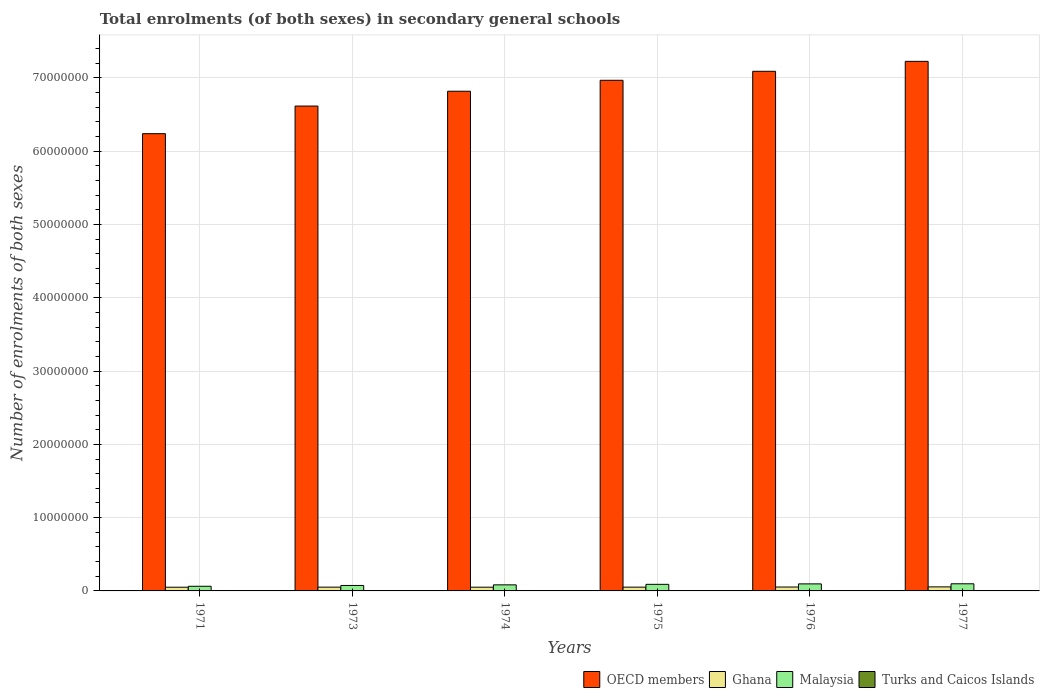Are the number of bars on each tick of the X-axis equal?
Keep it short and to the point. Yes. How many bars are there on the 6th tick from the left?
Your response must be concise. 4. How many bars are there on the 2nd tick from the right?
Give a very brief answer. 4. What is the label of the 6th group of bars from the left?
Give a very brief answer. 1977. In how many cases, is the number of bars for a given year not equal to the number of legend labels?
Offer a very short reply. 0. What is the number of enrolments in secondary schools in Turks and Caicos Islands in 1975?
Keep it short and to the point. 639. Across all years, what is the maximum number of enrolments in secondary schools in OECD members?
Give a very brief answer. 7.23e+07. Across all years, what is the minimum number of enrolments in secondary schools in OECD members?
Provide a short and direct response. 6.24e+07. In which year was the number of enrolments in secondary schools in OECD members minimum?
Your response must be concise. 1971. What is the total number of enrolments in secondary schools in Turks and Caicos Islands in the graph?
Your answer should be very brief. 3029. What is the difference between the number of enrolments in secondary schools in Turks and Caicos Islands in 1974 and that in 1977?
Provide a short and direct response. -204. What is the difference between the number of enrolments in secondary schools in Ghana in 1973 and the number of enrolments in secondary schools in Malaysia in 1974?
Make the answer very short. -3.13e+05. What is the average number of enrolments in secondary schools in OECD members per year?
Provide a succinct answer. 6.83e+07. In the year 1971, what is the difference between the number of enrolments in secondary schools in Ghana and number of enrolments in secondary schools in Malaysia?
Provide a short and direct response. -1.29e+05. In how many years, is the number of enrolments in secondary schools in Turks and Caicos Islands greater than 42000000?
Your response must be concise. 0. What is the ratio of the number of enrolments in secondary schools in Malaysia in 1974 to that in 1975?
Offer a terse response. 0.92. Is the difference between the number of enrolments in secondary schools in Ghana in 1974 and 1977 greater than the difference between the number of enrolments in secondary schools in Malaysia in 1974 and 1977?
Your answer should be compact. Yes. What is the difference between the highest and the second highest number of enrolments in secondary schools in Malaysia?
Make the answer very short. 1.25e+04. What is the difference between the highest and the lowest number of enrolments in secondary schools in Ghana?
Your answer should be very brief. 4.61e+04. Is the sum of the number of enrolments in secondary schools in Malaysia in 1974 and 1975 greater than the maximum number of enrolments in secondary schools in OECD members across all years?
Your response must be concise. No. What does the 3rd bar from the left in 1973 represents?
Ensure brevity in your answer.  Malaysia. How many bars are there?
Provide a succinct answer. 24. How many years are there in the graph?
Your answer should be compact. 6. Are the values on the major ticks of Y-axis written in scientific E-notation?
Give a very brief answer. No. Where does the legend appear in the graph?
Offer a very short reply. Bottom right. How many legend labels are there?
Your answer should be compact. 4. What is the title of the graph?
Give a very brief answer. Total enrolments (of both sexes) in secondary general schools. What is the label or title of the Y-axis?
Your answer should be compact. Number of enrolments of both sexes. What is the Number of enrolments of both sexes of OECD members in 1971?
Your answer should be very brief. 6.24e+07. What is the Number of enrolments of both sexes of Ghana in 1971?
Your answer should be very brief. 5.06e+05. What is the Number of enrolments of both sexes in Malaysia in 1971?
Provide a succinct answer. 6.35e+05. What is the Number of enrolments of both sexes of Turks and Caicos Islands in 1971?
Your answer should be very brief. 227. What is the Number of enrolments of both sexes in OECD members in 1973?
Your answer should be very brief. 6.62e+07. What is the Number of enrolments of both sexes of Ghana in 1973?
Provide a short and direct response. 5.16e+05. What is the Number of enrolments of both sexes of Malaysia in 1973?
Make the answer very short. 7.45e+05. What is the Number of enrolments of both sexes in Turks and Caicos Islands in 1973?
Offer a very short reply. 354. What is the Number of enrolments of both sexes of OECD members in 1974?
Ensure brevity in your answer.  6.82e+07. What is the Number of enrolments of both sexes in Ghana in 1974?
Your response must be concise. 5.09e+05. What is the Number of enrolments of both sexes of Malaysia in 1974?
Ensure brevity in your answer.  8.29e+05. What is the Number of enrolments of both sexes of Turks and Caicos Islands in 1974?
Provide a succinct answer. 467. What is the Number of enrolments of both sexes of OECD members in 1975?
Keep it short and to the point. 6.97e+07. What is the Number of enrolments of both sexes in Ghana in 1975?
Provide a short and direct response. 5.14e+05. What is the Number of enrolments of both sexes of Malaysia in 1975?
Make the answer very short. 9.00e+05. What is the Number of enrolments of both sexes in Turks and Caicos Islands in 1975?
Your response must be concise. 639. What is the Number of enrolments of both sexes in OECD members in 1976?
Your answer should be very brief. 7.09e+07. What is the Number of enrolments of both sexes of Ghana in 1976?
Offer a very short reply. 5.33e+05. What is the Number of enrolments of both sexes of Malaysia in 1976?
Offer a very short reply. 9.61e+05. What is the Number of enrolments of both sexes in Turks and Caicos Islands in 1976?
Provide a succinct answer. 671. What is the Number of enrolments of both sexes in OECD members in 1977?
Give a very brief answer. 7.23e+07. What is the Number of enrolments of both sexes in Ghana in 1977?
Your answer should be very brief. 5.52e+05. What is the Number of enrolments of both sexes of Malaysia in 1977?
Offer a terse response. 9.74e+05. What is the Number of enrolments of both sexes in Turks and Caicos Islands in 1977?
Keep it short and to the point. 671. Across all years, what is the maximum Number of enrolments of both sexes in OECD members?
Your answer should be very brief. 7.23e+07. Across all years, what is the maximum Number of enrolments of both sexes in Ghana?
Give a very brief answer. 5.52e+05. Across all years, what is the maximum Number of enrolments of both sexes in Malaysia?
Make the answer very short. 9.74e+05. Across all years, what is the maximum Number of enrolments of both sexes in Turks and Caicos Islands?
Provide a succinct answer. 671. Across all years, what is the minimum Number of enrolments of both sexes in OECD members?
Your response must be concise. 6.24e+07. Across all years, what is the minimum Number of enrolments of both sexes in Ghana?
Your answer should be compact. 5.06e+05. Across all years, what is the minimum Number of enrolments of both sexes in Malaysia?
Make the answer very short. 6.35e+05. Across all years, what is the minimum Number of enrolments of both sexes of Turks and Caicos Islands?
Provide a succinct answer. 227. What is the total Number of enrolments of both sexes of OECD members in the graph?
Your answer should be very brief. 4.10e+08. What is the total Number of enrolments of both sexes of Ghana in the graph?
Offer a very short reply. 3.13e+06. What is the total Number of enrolments of both sexes of Malaysia in the graph?
Your response must be concise. 5.04e+06. What is the total Number of enrolments of both sexes of Turks and Caicos Islands in the graph?
Provide a short and direct response. 3029. What is the difference between the Number of enrolments of both sexes of OECD members in 1971 and that in 1973?
Offer a terse response. -3.77e+06. What is the difference between the Number of enrolments of both sexes of Ghana in 1971 and that in 1973?
Provide a short and direct response. -9767. What is the difference between the Number of enrolments of both sexes in Malaysia in 1971 and that in 1973?
Provide a succinct answer. -1.10e+05. What is the difference between the Number of enrolments of both sexes of Turks and Caicos Islands in 1971 and that in 1973?
Your answer should be very brief. -127. What is the difference between the Number of enrolments of both sexes in OECD members in 1971 and that in 1974?
Offer a very short reply. -5.79e+06. What is the difference between the Number of enrolments of both sexes of Ghana in 1971 and that in 1974?
Offer a terse response. -2770. What is the difference between the Number of enrolments of both sexes in Malaysia in 1971 and that in 1974?
Your response must be concise. -1.94e+05. What is the difference between the Number of enrolments of both sexes of Turks and Caicos Islands in 1971 and that in 1974?
Offer a terse response. -240. What is the difference between the Number of enrolments of both sexes of OECD members in 1971 and that in 1975?
Your response must be concise. -7.29e+06. What is the difference between the Number of enrolments of both sexes in Ghana in 1971 and that in 1975?
Ensure brevity in your answer.  -8537. What is the difference between the Number of enrolments of both sexes in Malaysia in 1971 and that in 1975?
Give a very brief answer. -2.64e+05. What is the difference between the Number of enrolments of both sexes of Turks and Caicos Islands in 1971 and that in 1975?
Your answer should be very brief. -412. What is the difference between the Number of enrolments of both sexes of OECD members in 1971 and that in 1976?
Offer a very short reply. -8.51e+06. What is the difference between the Number of enrolments of both sexes in Ghana in 1971 and that in 1976?
Provide a short and direct response. -2.67e+04. What is the difference between the Number of enrolments of both sexes in Malaysia in 1971 and that in 1976?
Offer a terse response. -3.26e+05. What is the difference between the Number of enrolments of both sexes in Turks and Caicos Islands in 1971 and that in 1976?
Your answer should be compact. -444. What is the difference between the Number of enrolments of both sexes in OECD members in 1971 and that in 1977?
Ensure brevity in your answer.  -9.87e+06. What is the difference between the Number of enrolments of both sexes of Ghana in 1971 and that in 1977?
Provide a succinct answer. -4.61e+04. What is the difference between the Number of enrolments of both sexes in Malaysia in 1971 and that in 1977?
Offer a terse response. -3.39e+05. What is the difference between the Number of enrolments of both sexes of Turks and Caicos Islands in 1971 and that in 1977?
Provide a short and direct response. -444. What is the difference between the Number of enrolments of both sexes of OECD members in 1973 and that in 1974?
Offer a very short reply. -2.02e+06. What is the difference between the Number of enrolments of both sexes of Ghana in 1973 and that in 1974?
Give a very brief answer. 6997. What is the difference between the Number of enrolments of both sexes of Malaysia in 1973 and that in 1974?
Give a very brief answer. -8.42e+04. What is the difference between the Number of enrolments of both sexes of Turks and Caicos Islands in 1973 and that in 1974?
Your answer should be very brief. -113. What is the difference between the Number of enrolments of both sexes of OECD members in 1973 and that in 1975?
Offer a very short reply. -3.52e+06. What is the difference between the Number of enrolments of both sexes of Ghana in 1973 and that in 1975?
Provide a short and direct response. 1230. What is the difference between the Number of enrolments of both sexes in Malaysia in 1973 and that in 1975?
Offer a very short reply. -1.55e+05. What is the difference between the Number of enrolments of both sexes in Turks and Caicos Islands in 1973 and that in 1975?
Ensure brevity in your answer.  -285. What is the difference between the Number of enrolments of both sexes of OECD members in 1973 and that in 1976?
Your answer should be very brief. -4.75e+06. What is the difference between the Number of enrolments of both sexes of Ghana in 1973 and that in 1976?
Offer a terse response. -1.70e+04. What is the difference between the Number of enrolments of both sexes in Malaysia in 1973 and that in 1976?
Provide a short and direct response. -2.16e+05. What is the difference between the Number of enrolments of both sexes in Turks and Caicos Islands in 1973 and that in 1976?
Give a very brief answer. -317. What is the difference between the Number of enrolments of both sexes of OECD members in 1973 and that in 1977?
Offer a terse response. -6.10e+06. What is the difference between the Number of enrolments of both sexes in Ghana in 1973 and that in 1977?
Offer a very short reply. -3.63e+04. What is the difference between the Number of enrolments of both sexes of Malaysia in 1973 and that in 1977?
Give a very brief answer. -2.29e+05. What is the difference between the Number of enrolments of both sexes of Turks and Caicos Islands in 1973 and that in 1977?
Your answer should be very brief. -317. What is the difference between the Number of enrolments of both sexes in OECD members in 1974 and that in 1975?
Your answer should be very brief. -1.49e+06. What is the difference between the Number of enrolments of both sexes of Ghana in 1974 and that in 1975?
Offer a terse response. -5767. What is the difference between the Number of enrolments of both sexes in Malaysia in 1974 and that in 1975?
Provide a succinct answer. -7.07e+04. What is the difference between the Number of enrolments of both sexes in Turks and Caicos Islands in 1974 and that in 1975?
Make the answer very short. -172. What is the difference between the Number of enrolments of both sexes of OECD members in 1974 and that in 1976?
Your answer should be very brief. -2.72e+06. What is the difference between the Number of enrolments of both sexes of Ghana in 1974 and that in 1976?
Provide a succinct answer. -2.40e+04. What is the difference between the Number of enrolments of both sexes in Malaysia in 1974 and that in 1976?
Provide a short and direct response. -1.32e+05. What is the difference between the Number of enrolments of both sexes of Turks and Caicos Islands in 1974 and that in 1976?
Provide a short and direct response. -204. What is the difference between the Number of enrolments of both sexes in OECD members in 1974 and that in 1977?
Provide a short and direct response. -4.08e+06. What is the difference between the Number of enrolments of both sexes in Ghana in 1974 and that in 1977?
Offer a very short reply. -4.33e+04. What is the difference between the Number of enrolments of both sexes of Malaysia in 1974 and that in 1977?
Offer a very short reply. -1.45e+05. What is the difference between the Number of enrolments of both sexes of Turks and Caicos Islands in 1974 and that in 1977?
Your response must be concise. -204. What is the difference between the Number of enrolments of both sexes of OECD members in 1975 and that in 1976?
Make the answer very short. -1.23e+06. What is the difference between the Number of enrolments of both sexes of Ghana in 1975 and that in 1976?
Your answer should be compact. -1.82e+04. What is the difference between the Number of enrolments of both sexes in Malaysia in 1975 and that in 1976?
Make the answer very short. -6.16e+04. What is the difference between the Number of enrolments of both sexes of Turks and Caicos Islands in 1975 and that in 1976?
Give a very brief answer. -32. What is the difference between the Number of enrolments of both sexes in OECD members in 1975 and that in 1977?
Provide a short and direct response. -2.58e+06. What is the difference between the Number of enrolments of both sexes of Ghana in 1975 and that in 1977?
Offer a very short reply. -3.76e+04. What is the difference between the Number of enrolments of both sexes of Malaysia in 1975 and that in 1977?
Your response must be concise. -7.41e+04. What is the difference between the Number of enrolments of both sexes in Turks and Caicos Islands in 1975 and that in 1977?
Your answer should be very brief. -32. What is the difference between the Number of enrolments of both sexes in OECD members in 1976 and that in 1977?
Offer a very short reply. -1.36e+06. What is the difference between the Number of enrolments of both sexes of Ghana in 1976 and that in 1977?
Keep it short and to the point. -1.94e+04. What is the difference between the Number of enrolments of both sexes in Malaysia in 1976 and that in 1977?
Make the answer very short. -1.25e+04. What is the difference between the Number of enrolments of both sexes in Turks and Caicos Islands in 1976 and that in 1977?
Provide a short and direct response. 0. What is the difference between the Number of enrolments of both sexes of OECD members in 1971 and the Number of enrolments of both sexes of Ghana in 1973?
Offer a terse response. 6.19e+07. What is the difference between the Number of enrolments of both sexes in OECD members in 1971 and the Number of enrolments of both sexes in Malaysia in 1973?
Keep it short and to the point. 6.17e+07. What is the difference between the Number of enrolments of both sexes in OECD members in 1971 and the Number of enrolments of both sexes in Turks and Caicos Islands in 1973?
Your response must be concise. 6.24e+07. What is the difference between the Number of enrolments of both sexes of Ghana in 1971 and the Number of enrolments of both sexes of Malaysia in 1973?
Your answer should be compact. -2.39e+05. What is the difference between the Number of enrolments of both sexes in Ghana in 1971 and the Number of enrolments of both sexes in Turks and Caicos Islands in 1973?
Offer a very short reply. 5.05e+05. What is the difference between the Number of enrolments of both sexes in Malaysia in 1971 and the Number of enrolments of both sexes in Turks and Caicos Islands in 1973?
Give a very brief answer. 6.35e+05. What is the difference between the Number of enrolments of both sexes in OECD members in 1971 and the Number of enrolments of both sexes in Ghana in 1974?
Your response must be concise. 6.19e+07. What is the difference between the Number of enrolments of both sexes in OECD members in 1971 and the Number of enrolments of both sexes in Malaysia in 1974?
Make the answer very short. 6.16e+07. What is the difference between the Number of enrolments of both sexes in OECD members in 1971 and the Number of enrolments of both sexes in Turks and Caicos Islands in 1974?
Keep it short and to the point. 6.24e+07. What is the difference between the Number of enrolments of both sexes in Ghana in 1971 and the Number of enrolments of both sexes in Malaysia in 1974?
Your answer should be very brief. -3.23e+05. What is the difference between the Number of enrolments of both sexes in Ghana in 1971 and the Number of enrolments of both sexes in Turks and Caicos Islands in 1974?
Offer a terse response. 5.05e+05. What is the difference between the Number of enrolments of both sexes of Malaysia in 1971 and the Number of enrolments of both sexes of Turks and Caicos Islands in 1974?
Give a very brief answer. 6.35e+05. What is the difference between the Number of enrolments of both sexes in OECD members in 1971 and the Number of enrolments of both sexes in Ghana in 1975?
Your response must be concise. 6.19e+07. What is the difference between the Number of enrolments of both sexes in OECD members in 1971 and the Number of enrolments of both sexes in Malaysia in 1975?
Provide a succinct answer. 6.15e+07. What is the difference between the Number of enrolments of both sexes of OECD members in 1971 and the Number of enrolments of both sexes of Turks and Caicos Islands in 1975?
Provide a short and direct response. 6.24e+07. What is the difference between the Number of enrolments of both sexes in Ghana in 1971 and the Number of enrolments of both sexes in Malaysia in 1975?
Your answer should be very brief. -3.94e+05. What is the difference between the Number of enrolments of both sexes in Ghana in 1971 and the Number of enrolments of both sexes in Turks and Caicos Islands in 1975?
Provide a succinct answer. 5.05e+05. What is the difference between the Number of enrolments of both sexes of Malaysia in 1971 and the Number of enrolments of both sexes of Turks and Caicos Islands in 1975?
Ensure brevity in your answer.  6.35e+05. What is the difference between the Number of enrolments of both sexes in OECD members in 1971 and the Number of enrolments of both sexes in Ghana in 1976?
Your answer should be compact. 6.19e+07. What is the difference between the Number of enrolments of both sexes in OECD members in 1971 and the Number of enrolments of both sexes in Malaysia in 1976?
Your response must be concise. 6.14e+07. What is the difference between the Number of enrolments of both sexes of OECD members in 1971 and the Number of enrolments of both sexes of Turks and Caicos Islands in 1976?
Give a very brief answer. 6.24e+07. What is the difference between the Number of enrolments of both sexes of Ghana in 1971 and the Number of enrolments of both sexes of Malaysia in 1976?
Ensure brevity in your answer.  -4.56e+05. What is the difference between the Number of enrolments of both sexes of Ghana in 1971 and the Number of enrolments of both sexes of Turks and Caicos Islands in 1976?
Your answer should be compact. 5.05e+05. What is the difference between the Number of enrolments of both sexes in Malaysia in 1971 and the Number of enrolments of both sexes in Turks and Caicos Islands in 1976?
Give a very brief answer. 6.35e+05. What is the difference between the Number of enrolments of both sexes of OECD members in 1971 and the Number of enrolments of both sexes of Ghana in 1977?
Give a very brief answer. 6.18e+07. What is the difference between the Number of enrolments of both sexes of OECD members in 1971 and the Number of enrolments of both sexes of Malaysia in 1977?
Provide a succinct answer. 6.14e+07. What is the difference between the Number of enrolments of both sexes of OECD members in 1971 and the Number of enrolments of both sexes of Turks and Caicos Islands in 1977?
Provide a succinct answer. 6.24e+07. What is the difference between the Number of enrolments of both sexes of Ghana in 1971 and the Number of enrolments of both sexes of Malaysia in 1977?
Make the answer very short. -4.68e+05. What is the difference between the Number of enrolments of both sexes of Ghana in 1971 and the Number of enrolments of both sexes of Turks and Caicos Islands in 1977?
Your response must be concise. 5.05e+05. What is the difference between the Number of enrolments of both sexes of Malaysia in 1971 and the Number of enrolments of both sexes of Turks and Caicos Islands in 1977?
Provide a succinct answer. 6.35e+05. What is the difference between the Number of enrolments of both sexes in OECD members in 1973 and the Number of enrolments of both sexes in Ghana in 1974?
Offer a terse response. 6.57e+07. What is the difference between the Number of enrolments of both sexes in OECD members in 1973 and the Number of enrolments of both sexes in Malaysia in 1974?
Make the answer very short. 6.53e+07. What is the difference between the Number of enrolments of both sexes of OECD members in 1973 and the Number of enrolments of both sexes of Turks and Caicos Islands in 1974?
Provide a short and direct response. 6.62e+07. What is the difference between the Number of enrolments of both sexes of Ghana in 1973 and the Number of enrolments of both sexes of Malaysia in 1974?
Offer a terse response. -3.13e+05. What is the difference between the Number of enrolments of both sexes in Ghana in 1973 and the Number of enrolments of both sexes in Turks and Caicos Islands in 1974?
Give a very brief answer. 5.15e+05. What is the difference between the Number of enrolments of both sexes of Malaysia in 1973 and the Number of enrolments of both sexes of Turks and Caicos Islands in 1974?
Provide a short and direct response. 7.44e+05. What is the difference between the Number of enrolments of both sexes of OECD members in 1973 and the Number of enrolments of both sexes of Ghana in 1975?
Your answer should be very brief. 6.57e+07. What is the difference between the Number of enrolments of both sexes in OECD members in 1973 and the Number of enrolments of both sexes in Malaysia in 1975?
Your answer should be compact. 6.53e+07. What is the difference between the Number of enrolments of both sexes in OECD members in 1973 and the Number of enrolments of both sexes in Turks and Caicos Islands in 1975?
Keep it short and to the point. 6.62e+07. What is the difference between the Number of enrolments of both sexes in Ghana in 1973 and the Number of enrolments of both sexes in Malaysia in 1975?
Your answer should be compact. -3.84e+05. What is the difference between the Number of enrolments of both sexes of Ghana in 1973 and the Number of enrolments of both sexes of Turks and Caicos Islands in 1975?
Give a very brief answer. 5.15e+05. What is the difference between the Number of enrolments of both sexes of Malaysia in 1973 and the Number of enrolments of both sexes of Turks and Caicos Islands in 1975?
Give a very brief answer. 7.44e+05. What is the difference between the Number of enrolments of both sexes in OECD members in 1973 and the Number of enrolments of both sexes in Ghana in 1976?
Ensure brevity in your answer.  6.56e+07. What is the difference between the Number of enrolments of both sexes in OECD members in 1973 and the Number of enrolments of both sexes in Malaysia in 1976?
Make the answer very short. 6.52e+07. What is the difference between the Number of enrolments of both sexes of OECD members in 1973 and the Number of enrolments of both sexes of Turks and Caicos Islands in 1976?
Your answer should be compact. 6.62e+07. What is the difference between the Number of enrolments of both sexes in Ghana in 1973 and the Number of enrolments of both sexes in Malaysia in 1976?
Ensure brevity in your answer.  -4.46e+05. What is the difference between the Number of enrolments of both sexes of Ghana in 1973 and the Number of enrolments of both sexes of Turks and Caicos Islands in 1976?
Provide a succinct answer. 5.15e+05. What is the difference between the Number of enrolments of both sexes in Malaysia in 1973 and the Number of enrolments of both sexes in Turks and Caicos Islands in 1976?
Offer a very short reply. 7.44e+05. What is the difference between the Number of enrolments of both sexes of OECD members in 1973 and the Number of enrolments of both sexes of Ghana in 1977?
Provide a succinct answer. 6.56e+07. What is the difference between the Number of enrolments of both sexes in OECD members in 1973 and the Number of enrolments of both sexes in Malaysia in 1977?
Provide a short and direct response. 6.52e+07. What is the difference between the Number of enrolments of both sexes of OECD members in 1973 and the Number of enrolments of both sexes of Turks and Caicos Islands in 1977?
Give a very brief answer. 6.62e+07. What is the difference between the Number of enrolments of both sexes of Ghana in 1973 and the Number of enrolments of both sexes of Malaysia in 1977?
Give a very brief answer. -4.58e+05. What is the difference between the Number of enrolments of both sexes in Ghana in 1973 and the Number of enrolments of both sexes in Turks and Caicos Islands in 1977?
Give a very brief answer. 5.15e+05. What is the difference between the Number of enrolments of both sexes in Malaysia in 1973 and the Number of enrolments of both sexes in Turks and Caicos Islands in 1977?
Make the answer very short. 7.44e+05. What is the difference between the Number of enrolments of both sexes in OECD members in 1974 and the Number of enrolments of both sexes in Ghana in 1975?
Offer a very short reply. 6.77e+07. What is the difference between the Number of enrolments of both sexes of OECD members in 1974 and the Number of enrolments of both sexes of Malaysia in 1975?
Give a very brief answer. 6.73e+07. What is the difference between the Number of enrolments of both sexes of OECD members in 1974 and the Number of enrolments of both sexes of Turks and Caicos Islands in 1975?
Make the answer very short. 6.82e+07. What is the difference between the Number of enrolments of both sexes of Ghana in 1974 and the Number of enrolments of both sexes of Malaysia in 1975?
Make the answer very short. -3.91e+05. What is the difference between the Number of enrolments of both sexes in Ghana in 1974 and the Number of enrolments of both sexes in Turks and Caicos Islands in 1975?
Give a very brief answer. 5.08e+05. What is the difference between the Number of enrolments of both sexes of Malaysia in 1974 and the Number of enrolments of both sexes of Turks and Caicos Islands in 1975?
Offer a terse response. 8.28e+05. What is the difference between the Number of enrolments of both sexes in OECD members in 1974 and the Number of enrolments of both sexes in Ghana in 1976?
Provide a succinct answer. 6.77e+07. What is the difference between the Number of enrolments of both sexes in OECD members in 1974 and the Number of enrolments of both sexes in Malaysia in 1976?
Offer a very short reply. 6.72e+07. What is the difference between the Number of enrolments of both sexes of OECD members in 1974 and the Number of enrolments of both sexes of Turks and Caicos Islands in 1976?
Ensure brevity in your answer.  6.82e+07. What is the difference between the Number of enrolments of both sexes of Ghana in 1974 and the Number of enrolments of both sexes of Malaysia in 1976?
Provide a succinct answer. -4.53e+05. What is the difference between the Number of enrolments of both sexes of Ghana in 1974 and the Number of enrolments of both sexes of Turks and Caicos Islands in 1976?
Your answer should be very brief. 5.08e+05. What is the difference between the Number of enrolments of both sexes of Malaysia in 1974 and the Number of enrolments of both sexes of Turks and Caicos Islands in 1976?
Keep it short and to the point. 8.28e+05. What is the difference between the Number of enrolments of both sexes of OECD members in 1974 and the Number of enrolments of both sexes of Ghana in 1977?
Give a very brief answer. 6.76e+07. What is the difference between the Number of enrolments of both sexes of OECD members in 1974 and the Number of enrolments of both sexes of Malaysia in 1977?
Offer a very short reply. 6.72e+07. What is the difference between the Number of enrolments of both sexes in OECD members in 1974 and the Number of enrolments of both sexes in Turks and Caicos Islands in 1977?
Make the answer very short. 6.82e+07. What is the difference between the Number of enrolments of both sexes of Ghana in 1974 and the Number of enrolments of both sexes of Malaysia in 1977?
Offer a terse response. -4.65e+05. What is the difference between the Number of enrolments of both sexes in Ghana in 1974 and the Number of enrolments of both sexes in Turks and Caicos Islands in 1977?
Keep it short and to the point. 5.08e+05. What is the difference between the Number of enrolments of both sexes in Malaysia in 1974 and the Number of enrolments of both sexes in Turks and Caicos Islands in 1977?
Make the answer very short. 8.28e+05. What is the difference between the Number of enrolments of both sexes of OECD members in 1975 and the Number of enrolments of both sexes of Ghana in 1976?
Give a very brief answer. 6.92e+07. What is the difference between the Number of enrolments of both sexes of OECD members in 1975 and the Number of enrolments of both sexes of Malaysia in 1976?
Offer a terse response. 6.87e+07. What is the difference between the Number of enrolments of both sexes in OECD members in 1975 and the Number of enrolments of both sexes in Turks and Caicos Islands in 1976?
Give a very brief answer. 6.97e+07. What is the difference between the Number of enrolments of both sexes in Ghana in 1975 and the Number of enrolments of both sexes in Malaysia in 1976?
Provide a short and direct response. -4.47e+05. What is the difference between the Number of enrolments of both sexes of Ghana in 1975 and the Number of enrolments of both sexes of Turks and Caicos Islands in 1976?
Provide a succinct answer. 5.14e+05. What is the difference between the Number of enrolments of both sexes of Malaysia in 1975 and the Number of enrolments of both sexes of Turks and Caicos Islands in 1976?
Ensure brevity in your answer.  8.99e+05. What is the difference between the Number of enrolments of both sexes of OECD members in 1975 and the Number of enrolments of both sexes of Ghana in 1977?
Make the answer very short. 6.91e+07. What is the difference between the Number of enrolments of both sexes in OECD members in 1975 and the Number of enrolments of both sexes in Malaysia in 1977?
Offer a terse response. 6.87e+07. What is the difference between the Number of enrolments of both sexes in OECD members in 1975 and the Number of enrolments of both sexes in Turks and Caicos Islands in 1977?
Keep it short and to the point. 6.97e+07. What is the difference between the Number of enrolments of both sexes in Ghana in 1975 and the Number of enrolments of both sexes in Malaysia in 1977?
Your answer should be compact. -4.59e+05. What is the difference between the Number of enrolments of both sexes of Ghana in 1975 and the Number of enrolments of both sexes of Turks and Caicos Islands in 1977?
Make the answer very short. 5.14e+05. What is the difference between the Number of enrolments of both sexes in Malaysia in 1975 and the Number of enrolments of both sexes in Turks and Caicos Islands in 1977?
Provide a succinct answer. 8.99e+05. What is the difference between the Number of enrolments of both sexes of OECD members in 1976 and the Number of enrolments of both sexes of Ghana in 1977?
Provide a short and direct response. 7.04e+07. What is the difference between the Number of enrolments of both sexes of OECD members in 1976 and the Number of enrolments of both sexes of Malaysia in 1977?
Provide a succinct answer. 6.99e+07. What is the difference between the Number of enrolments of both sexes in OECD members in 1976 and the Number of enrolments of both sexes in Turks and Caicos Islands in 1977?
Keep it short and to the point. 7.09e+07. What is the difference between the Number of enrolments of both sexes of Ghana in 1976 and the Number of enrolments of both sexes of Malaysia in 1977?
Keep it short and to the point. -4.41e+05. What is the difference between the Number of enrolments of both sexes in Ghana in 1976 and the Number of enrolments of both sexes in Turks and Caicos Islands in 1977?
Your answer should be very brief. 5.32e+05. What is the difference between the Number of enrolments of both sexes in Malaysia in 1976 and the Number of enrolments of both sexes in Turks and Caicos Islands in 1977?
Keep it short and to the point. 9.61e+05. What is the average Number of enrolments of both sexes in OECD members per year?
Your answer should be compact. 6.83e+07. What is the average Number of enrolments of both sexes of Ghana per year?
Make the answer very short. 5.21e+05. What is the average Number of enrolments of both sexes of Malaysia per year?
Offer a terse response. 8.41e+05. What is the average Number of enrolments of both sexes in Turks and Caicos Islands per year?
Ensure brevity in your answer.  504.83. In the year 1971, what is the difference between the Number of enrolments of both sexes of OECD members and Number of enrolments of both sexes of Ghana?
Your answer should be very brief. 6.19e+07. In the year 1971, what is the difference between the Number of enrolments of both sexes of OECD members and Number of enrolments of both sexes of Malaysia?
Provide a short and direct response. 6.18e+07. In the year 1971, what is the difference between the Number of enrolments of both sexes in OECD members and Number of enrolments of both sexes in Turks and Caicos Islands?
Provide a succinct answer. 6.24e+07. In the year 1971, what is the difference between the Number of enrolments of both sexes in Ghana and Number of enrolments of both sexes in Malaysia?
Give a very brief answer. -1.29e+05. In the year 1971, what is the difference between the Number of enrolments of both sexes of Ghana and Number of enrolments of both sexes of Turks and Caicos Islands?
Your answer should be compact. 5.06e+05. In the year 1971, what is the difference between the Number of enrolments of both sexes in Malaysia and Number of enrolments of both sexes in Turks and Caicos Islands?
Keep it short and to the point. 6.35e+05. In the year 1973, what is the difference between the Number of enrolments of both sexes in OECD members and Number of enrolments of both sexes in Ghana?
Offer a very short reply. 6.57e+07. In the year 1973, what is the difference between the Number of enrolments of both sexes of OECD members and Number of enrolments of both sexes of Malaysia?
Your response must be concise. 6.54e+07. In the year 1973, what is the difference between the Number of enrolments of both sexes in OECD members and Number of enrolments of both sexes in Turks and Caicos Islands?
Your answer should be compact. 6.62e+07. In the year 1973, what is the difference between the Number of enrolments of both sexes of Ghana and Number of enrolments of both sexes of Malaysia?
Give a very brief answer. -2.29e+05. In the year 1973, what is the difference between the Number of enrolments of both sexes of Ghana and Number of enrolments of both sexes of Turks and Caicos Islands?
Offer a terse response. 5.15e+05. In the year 1973, what is the difference between the Number of enrolments of both sexes in Malaysia and Number of enrolments of both sexes in Turks and Caicos Islands?
Your response must be concise. 7.44e+05. In the year 1974, what is the difference between the Number of enrolments of both sexes in OECD members and Number of enrolments of both sexes in Ghana?
Provide a short and direct response. 6.77e+07. In the year 1974, what is the difference between the Number of enrolments of both sexes in OECD members and Number of enrolments of both sexes in Malaysia?
Give a very brief answer. 6.74e+07. In the year 1974, what is the difference between the Number of enrolments of both sexes in OECD members and Number of enrolments of both sexes in Turks and Caicos Islands?
Give a very brief answer. 6.82e+07. In the year 1974, what is the difference between the Number of enrolments of both sexes in Ghana and Number of enrolments of both sexes in Malaysia?
Give a very brief answer. -3.20e+05. In the year 1974, what is the difference between the Number of enrolments of both sexes in Ghana and Number of enrolments of both sexes in Turks and Caicos Islands?
Make the answer very short. 5.08e+05. In the year 1974, what is the difference between the Number of enrolments of both sexes of Malaysia and Number of enrolments of both sexes of Turks and Caicos Islands?
Offer a terse response. 8.28e+05. In the year 1975, what is the difference between the Number of enrolments of both sexes in OECD members and Number of enrolments of both sexes in Ghana?
Give a very brief answer. 6.92e+07. In the year 1975, what is the difference between the Number of enrolments of both sexes in OECD members and Number of enrolments of both sexes in Malaysia?
Your response must be concise. 6.88e+07. In the year 1975, what is the difference between the Number of enrolments of both sexes of OECD members and Number of enrolments of both sexes of Turks and Caicos Islands?
Provide a succinct answer. 6.97e+07. In the year 1975, what is the difference between the Number of enrolments of both sexes of Ghana and Number of enrolments of both sexes of Malaysia?
Give a very brief answer. -3.85e+05. In the year 1975, what is the difference between the Number of enrolments of both sexes in Ghana and Number of enrolments of both sexes in Turks and Caicos Islands?
Keep it short and to the point. 5.14e+05. In the year 1975, what is the difference between the Number of enrolments of both sexes in Malaysia and Number of enrolments of both sexes in Turks and Caicos Islands?
Your answer should be compact. 8.99e+05. In the year 1976, what is the difference between the Number of enrolments of both sexes in OECD members and Number of enrolments of both sexes in Ghana?
Your response must be concise. 7.04e+07. In the year 1976, what is the difference between the Number of enrolments of both sexes of OECD members and Number of enrolments of both sexes of Malaysia?
Your answer should be very brief. 7.00e+07. In the year 1976, what is the difference between the Number of enrolments of both sexes in OECD members and Number of enrolments of both sexes in Turks and Caicos Islands?
Your answer should be compact. 7.09e+07. In the year 1976, what is the difference between the Number of enrolments of both sexes of Ghana and Number of enrolments of both sexes of Malaysia?
Offer a very short reply. -4.29e+05. In the year 1976, what is the difference between the Number of enrolments of both sexes in Ghana and Number of enrolments of both sexes in Turks and Caicos Islands?
Offer a terse response. 5.32e+05. In the year 1976, what is the difference between the Number of enrolments of both sexes of Malaysia and Number of enrolments of both sexes of Turks and Caicos Islands?
Your response must be concise. 9.61e+05. In the year 1977, what is the difference between the Number of enrolments of both sexes in OECD members and Number of enrolments of both sexes in Ghana?
Ensure brevity in your answer.  7.17e+07. In the year 1977, what is the difference between the Number of enrolments of both sexes of OECD members and Number of enrolments of both sexes of Malaysia?
Your answer should be very brief. 7.13e+07. In the year 1977, what is the difference between the Number of enrolments of both sexes in OECD members and Number of enrolments of both sexes in Turks and Caicos Islands?
Give a very brief answer. 7.23e+07. In the year 1977, what is the difference between the Number of enrolments of both sexes of Ghana and Number of enrolments of both sexes of Malaysia?
Offer a very short reply. -4.22e+05. In the year 1977, what is the difference between the Number of enrolments of both sexes of Ghana and Number of enrolments of both sexes of Turks and Caicos Islands?
Provide a short and direct response. 5.51e+05. In the year 1977, what is the difference between the Number of enrolments of both sexes of Malaysia and Number of enrolments of both sexes of Turks and Caicos Islands?
Your answer should be very brief. 9.73e+05. What is the ratio of the Number of enrolments of both sexes of OECD members in 1971 to that in 1973?
Offer a very short reply. 0.94. What is the ratio of the Number of enrolments of both sexes of Ghana in 1971 to that in 1973?
Your response must be concise. 0.98. What is the ratio of the Number of enrolments of both sexes in Malaysia in 1971 to that in 1973?
Your answer should be compact. 0.85. What is the ratio of the Number of enrolments of both sexes of Turks and Caicos Islands in 1971 to that in 1973?
Provide a short and direct response. 0.64. What is the ratio of the Number of enrolments of both sexes of OECD members in 1971 to that in 1974?
Your answer should be very brief. 0.92. What is the ratio of the Number of enrolments of both sexes in Ghana in 1971 to that in 1974?
Give a very brief answer. 0.99. What is the ratio of the Number of enrolments of both sexes in Malaysia in 1971 to that in 1974?
Ensure brevity in your answer.  0.77. What is the ratio of the Number of enrolments of both sexes of Turks and Caicos Islands in 1971 to that in 1974?
Offer a terse response. 0.49. What is the ratio of the Number of enrolments of both sexes of OECD members in 1971 to that in 1975?
Keep it short and to the point. 0.9. What is the ratio of the Number of enrolments of both sexes in Ghana in 1971 to that in 1975?
Your response must be concise. 0.98. What is the ratio of the Number of enrolments of both sexes in Malaysia in 1971 to that in 1975?
Provide a succinct answer. 0.71. What is the ratio of the Number of enrolments of both sexes of Turks and Caicos Islands in 1971 to that in 1975?
Your response must be concise. 0.36. What is the ratio of the Number of enrolments of both sexes in OECD members in 1971 to that in 1976?
Give a very brief answer. 0.88. What is the ratio of the Number of enrolments of both sexes in Ghana in 1971 to that in 1976?
Offer a very short reply. 0.95. What is the ratio of the Number of enrolments of both sexes in Malaysia in 1971 to that in 1976?
Your answer should be very brief. 0.66. What is the ratio of the Number of enrolments of both sexes in Turks and Caicos Islands in 1971 to that in 1976?
Your answer should be compact. 0.34. What is the ratio of the Number of enrolments of both sexes in OECD members in 1971 to that in 1977?
Your answer should be compact. 0.86. What is the ratio of the Number of enrolments of both sexes in Ghana in 1971 to that in 1977?
Make the answer very short. 0.92. What is the ratio of the Number of enrolments of both sexes in Malaysia in 1971 to that in 1977?
Your answer should be very brief. 0.65. What is the ratio of the Number of enrolments of both sexes of Turks and Caicos Islands in 1971 to that in 1977?
Your answer should be very brief. 0.34. What is the ratio of the Number of enrolments of both sexes in OECD members in 1973 to that in 1974?
Your response must be concise. 0.97. What is the ratio of the Number of enrolments of both sexes in Ghana in 1973 to that in 1974?
Make the answer very short. 1.01. What is the ratio of the Number of enrolments of both sexes in Malaysia in 1973 to that in 1974?
Offer a very short reply. 0.9. What is the ratio of the Number of enrolments of both sexes in Turks and Caicos Islands in 1973 to that in 1974?
Provide a succinct answer. 0.76. What is the ratio of the Number of enrolments of both sexes of OECD members in 1973 to that in 1975?
Give a very brief answer. 0.95. What is the ratio of the Number of enrolments of both sexes in Ghana in 1973 to that in 1975?
Ensure brevity in your answer.  1. What is the ratio of the Number of enrolments of both sexes of Malaysia in 1973 to that in 1975?
Give a very brief answer. 0.83. What is the ratio of the Number of enrolments of both sexes of Turks and Caicos Islands in 1973 to that in 1975?
Provide a short and direct response. 0.55. What is the ratio of the Number of enrolments of both sexes in OECD members in 1973 to that in 1976?
Your response must be concise. 0.93. What is the ratio of the Number of enrolments of both sexes in Ghana in 1973 to that in 1976?
Your response must be concise. 0.97. What is the ratio of the Number of enrolments of both sexes in Malaysia in 1973 to that in 1976?
Offer a very short reply. 0.77. What is the ratio of the Number of enrolments of both sexes of Turks and Caicos Islands in 1973 to that in 1976?
Provide a short and direct response. 0.53. What is the ratio of the Number of enrolments of both sexes in OECD members in 1973 to that in 1977?
Provide a short and direct response. 0.92. What is the ratio of the Number of enrolments of both sexes in Ghana in 1973 to that in 1977?
Ensure brevity in your answer.  0.93. What is the ratio of the Number of enrolments of both sexes of Malaysia in 1973 to that in 1977?
Ensure brevity in your answer.  0.76. What is the ratio of the Number of enrolments of both sexes in Turks and Caicos Islands in 1973 to that in 1977?
Offer a terse response. 0.53. What is the ratio of the Number of enrolments of both sexes in OECD members in 1974 to that in 1975?
Make the answer very short. 0.98. What is the ratio of the Number of enrolments of both sexes in Ghana in 1974 to that in 1975?
Keep it short and to the point. 0.99. What is the ratio of the Number of enrolments of both sexes of Malaysia in 1974 to that in 1975?
Keep it short and to the point. 0.92. What is the ratio of the Number of enrolments of both sexes in Turks and Caicos Islands in 1974 to that in 1975?
Make the answer very short. 0.73. What is the ratio of the Number of enrolments of both sexes of OECD members in 1974 to that in 1976?
Offer a very short reply. 0.96. What is the ratio of the Number of enrolments of both sexes in Ghana in 1974 to that in 1976?
Ensure brevity in your answer.  0.95. What is the ratio of the Number of enrolments of both sexes of Malaysia in 1974 to that in 1976?
Provide a succinct answer. 0.86. What is the ratio of the Number of enrolments of both sexes in Turks and Caicos Islands in 1974 to that in 1976?
Your answer should be very brief. 0.7. What is the ratio of the Number of enrolments of both sexes in OECD members in 1974 to that in 1977?
Keep it short and to the point. 0.94. What is the ratio of the Number of enrolments of both sexes in Ghana in 1974 to that in 1977?
Provide a short and direct response. 0.92. What is the ratio of the Number of enrolments of both sexes in Malaysia in 1974 to that in 1977?
Ensure brevity in your answer.  0.85. What is the ratio of the Number of enrolments of both sexes of Turks and Caicos Islands in 1974 to that in 1977?
Offer a very short reply. 0.7. What is the ratio of the Number of enrolments of both sexes of OECD members in 1975 to that in 1976?
Provide a short and direct response. 0.98. What is the ratio of the Number of enrolments of both sexes in Ghana in 1975 to that in 1976?
Make the answer very short. 0.97. What is the ratio of the Number of enrolments of both sexes in Malaysia in 1975 to that in 1976?
Make the answer very short. 0.94. What is the ratio of the Number of enrolments of both sexes of Turks and Caicos Islands in 1975 to that in 1976?
Provide a succinct answer. 0.95. What is the ratio of the Number of enrolments of both sexes in OECD members in 1975 to that in 1977?
Offer a terse response. 0.96. What is the ratio of the Number of enrolments of both sexes in Ghana in 1975 to that in 1977?
Make the answer very short. 0.93. What is the ratio of the Number of enrolments of both sexes in Malaysia in 1975 to that in 1977?
Make the answer very short. 0.92. What is the ratio of the Number of enrolments of both sexes of Turks and Caicos Islands in 1975 to that in 1977?
Provide a short and direct response. 0.95. What is the ratio of the Number of enrolments of both sexes of OECD members in 1976 to that in 1977?
Make the answer very short. 0.98. What is the ratio of the Number of enrolments of both sexes of Ghana in 1976 to that in 1977?
Your response must be concise. 0.96. What is the ratio of the Number of enrolments of both sexes of Malaysia in 1976 to that in 1977?
Keep it short and to the point. 0.99. What is the ratio of the Number of enrolments of both sexes of Turks and Caicos Islands in 1976 to that in 1977?
Ensure brevity in your answer.  1. What is the difference between the highest and the second highest Number of enrolments of both sexes in OECD members?
Make the answer very short. 1.36e+06. What is the difference between the highest and the second highest Number of enrolments of both sexes of Ghana?
Your answer should be very brief. 1.94e+04. What is the difference between the highest and the second highest Number of enrolments of both sexes of Malaysia?
Keep it short and to the point. 1.25e+04. What is the difference between the highest and the second highest Number of enrolments of both sexes of Turks and Caicos Islands?
Keep it short and to the point. 0. What is the difference between the highest and the lowest Number of enrolments of both sexes of OECD members?
Make the answer very short. 9.87e+06. What is the difference between the highest and the lowest Number of enrolments of both sexes of Ghana?
Offer a terse response. 4.61e+04. What is the difference between the highest and the lowest Number of enrolments of both sexes of Malaysia?
Make the answer very short. 3.39e+05. What is the difference between the highest and the lowest Number of enrolments of both sexes in Turks and Caicos Islands?
Provide a succinct answer. 444. 